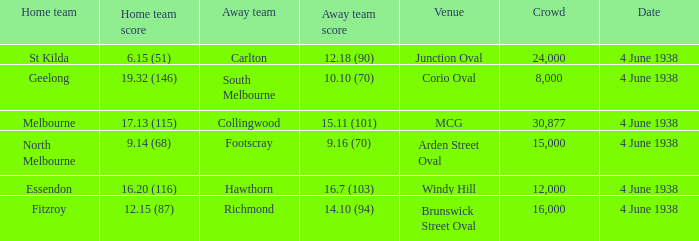How many attended the game at Arden Street Oval? 15000.0. 